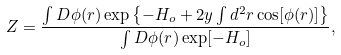<formula> <loc_0><loc_0><loc_500><loc_500>Z = { \frac { \int D \phi ( { r } ) \exp \left \{ - H _ { o } + 2 y \int d ^ { 2 } r \cos [ \phi ( { r } ) ] \right \} } { \int D \phi ( { r } ) \exp [ - H _ { o } ] } } ,</formula> 